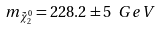Convert formula to latex. <formula><loc_0><loc_0><loc_500><loc_500>m _ { \tilde { \chi } ^ { 0 } _ { 2 } } = 2 2 8 . 2 \pm 5 \ G e V</formula> 